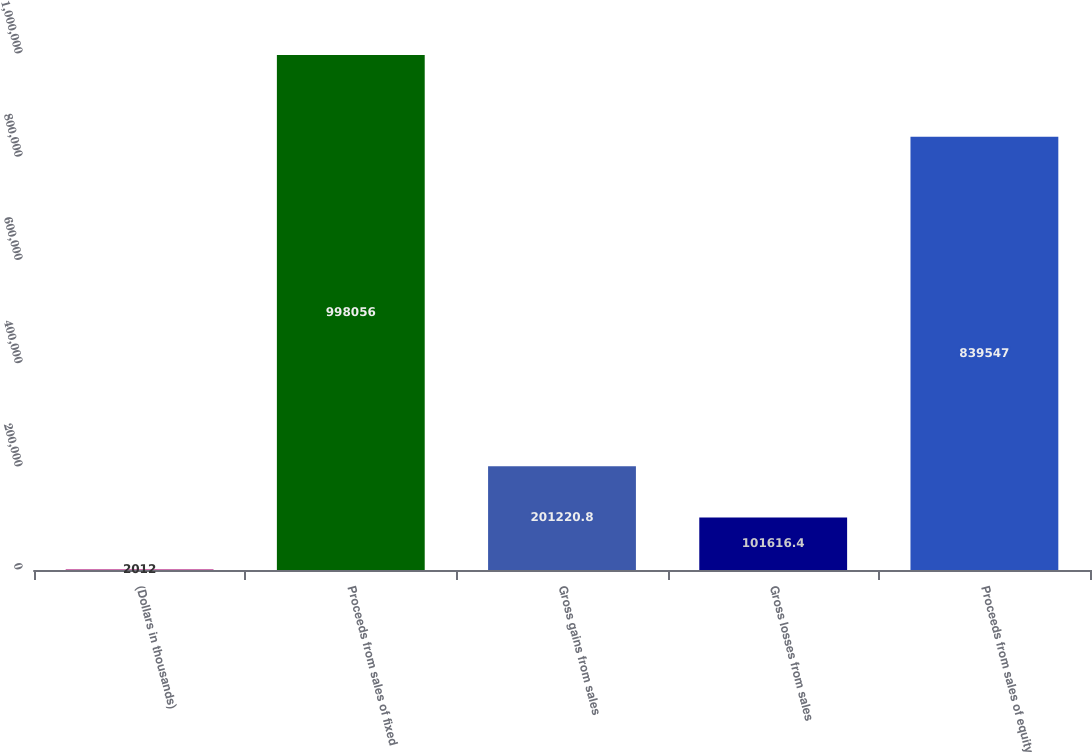Convert chart to OTSL. <chart><loc_0><loc_0><loc_500><loc_500><bar_chart><fcel>(Dollars in thousands)<fcel>Proceeds from sales of fixed<fcel>Gross gains from sales<fcel>Gross losses from sales<fcel>Proceeds from sales of equity<nl><fcel>2012<fcel>998056<fcel>201221<fcel>101616<fcel>839547<nl></chart> 